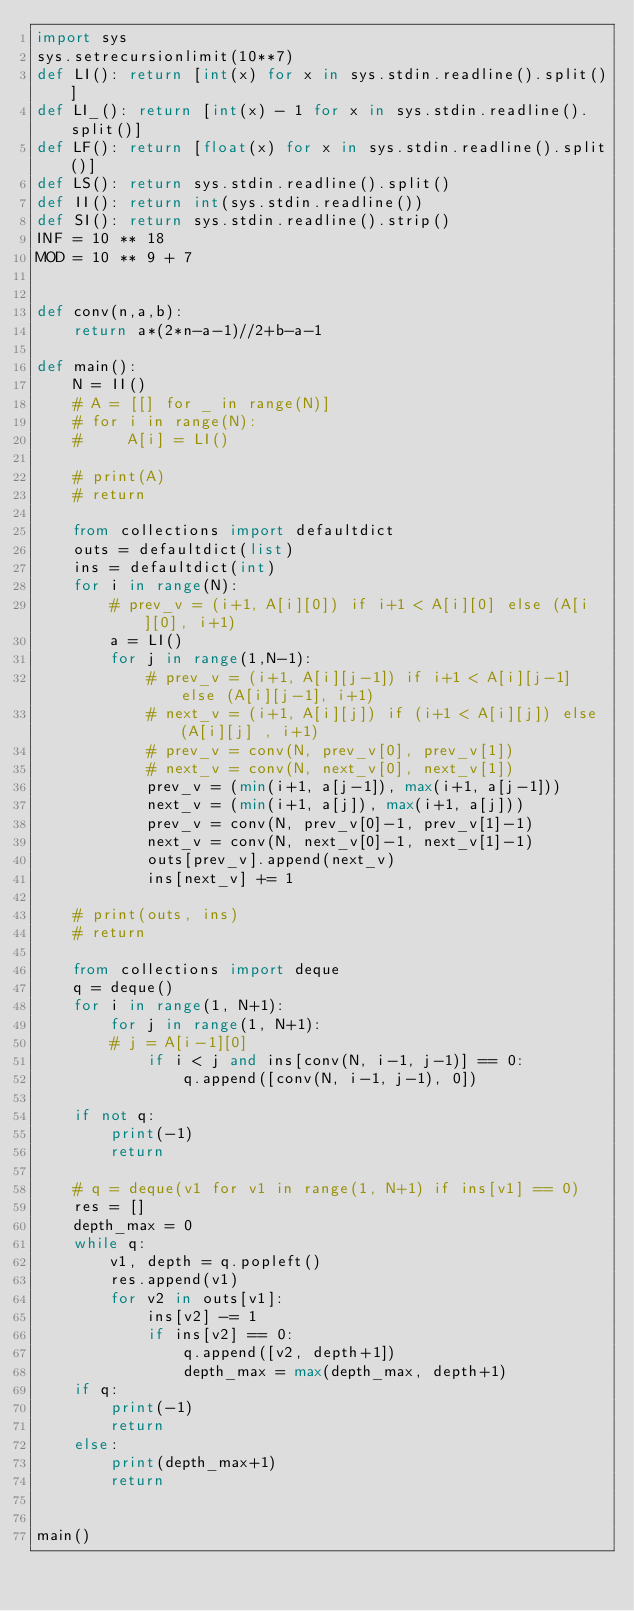<code> <loc_0><loc_0><loc_500><loc_500><_Python_>import sys
sys.setrecursionlimit(10**7)
def LI(): return [int(x) for x in sys.stdin.readline().split()]
def LI_(): return [int(x) - 1 for x in sys.stdin.readline().split()]
def LF(): return [float(x) for x in sys.stdin.readline().split()]
def LS(): return sys.stdin.readline().split()
def II(): return int(sys.stdin.readline())
def SI(): return sys.stdin.readline().strip()
INF = 10 ** 18
MOD = 10 ** 9 + 7


def conv(n,a,b):
    return a*(2*n-a-1)//2+b-a-1

def main(): 
    N = II()
    # A = [[] for _ in range(N)]
    # for i in range(N):
    #     A[i] = LI()

    # print(A)
    # return

    from collections import defaultdict
    outs = defaultdict(list)
    ins = defaultdict(int)
    for i in range(N):
        # prev_v = (i+1, A[i][0]) if i+1 < A[i][0] else (A[i][0], i+1)
        a = LI()
        for j in range(1,N-1):
            # prev_v = (i+1, A[i][j-1]) if i+1 < A[i][j-1] else (A[i][j-1], i+1)
            # next_v = (i+1, A[i][j]) if (i+1 < A[i][j]) else (A[i][j] , i+1)
            # prev_v = conv(N, prev_v[0], prev_v[1])
            # next_v = conv(N, next_v[0], next_v[1])
            prev_v = (min(i+1, a[j-1]), max(i+1, a[j-1]))
            next_v = (min(i+1, a[j]), max(i+1, a[j]))
            prev_v = conv(N, prev_v[0]-1, prev_v[1]-1)
            next_v = conv(N, next_v[0]-1, next_v[1]-1)
            outs[prev_v].append(next_v)
            ins[next_v] += 1

    # print(outs, ins)
    # return

    from collections import deque
    q = deque()
    for i in range(1, N+1):
        for j in range(1, N+1):
        # j = A[i-1][0]
            if i < j and ins[conv(N, i-1, j-1)] == 0:
                q.append([conv(N, i-1, j-1), 0])

    if not q:
        print(-1)
        return

    # q = deque(v1 for v1 in range(1, N+1) if ins[v1] == 0)
    res = []
    depth_max = 0
    while q:
        v1, depth = q.popleft()
        res.append(v1)
        for v2 in outs[v1]:
            ins[v2] -= 1
            if ins[v2] == 0:
                q.append([v2, depth+1])
                depth_max = max(depth_max, depth+1)
    if q:
        print(-1)
        return
    else:
        print(depth_max+1)
        return


main()</code> 